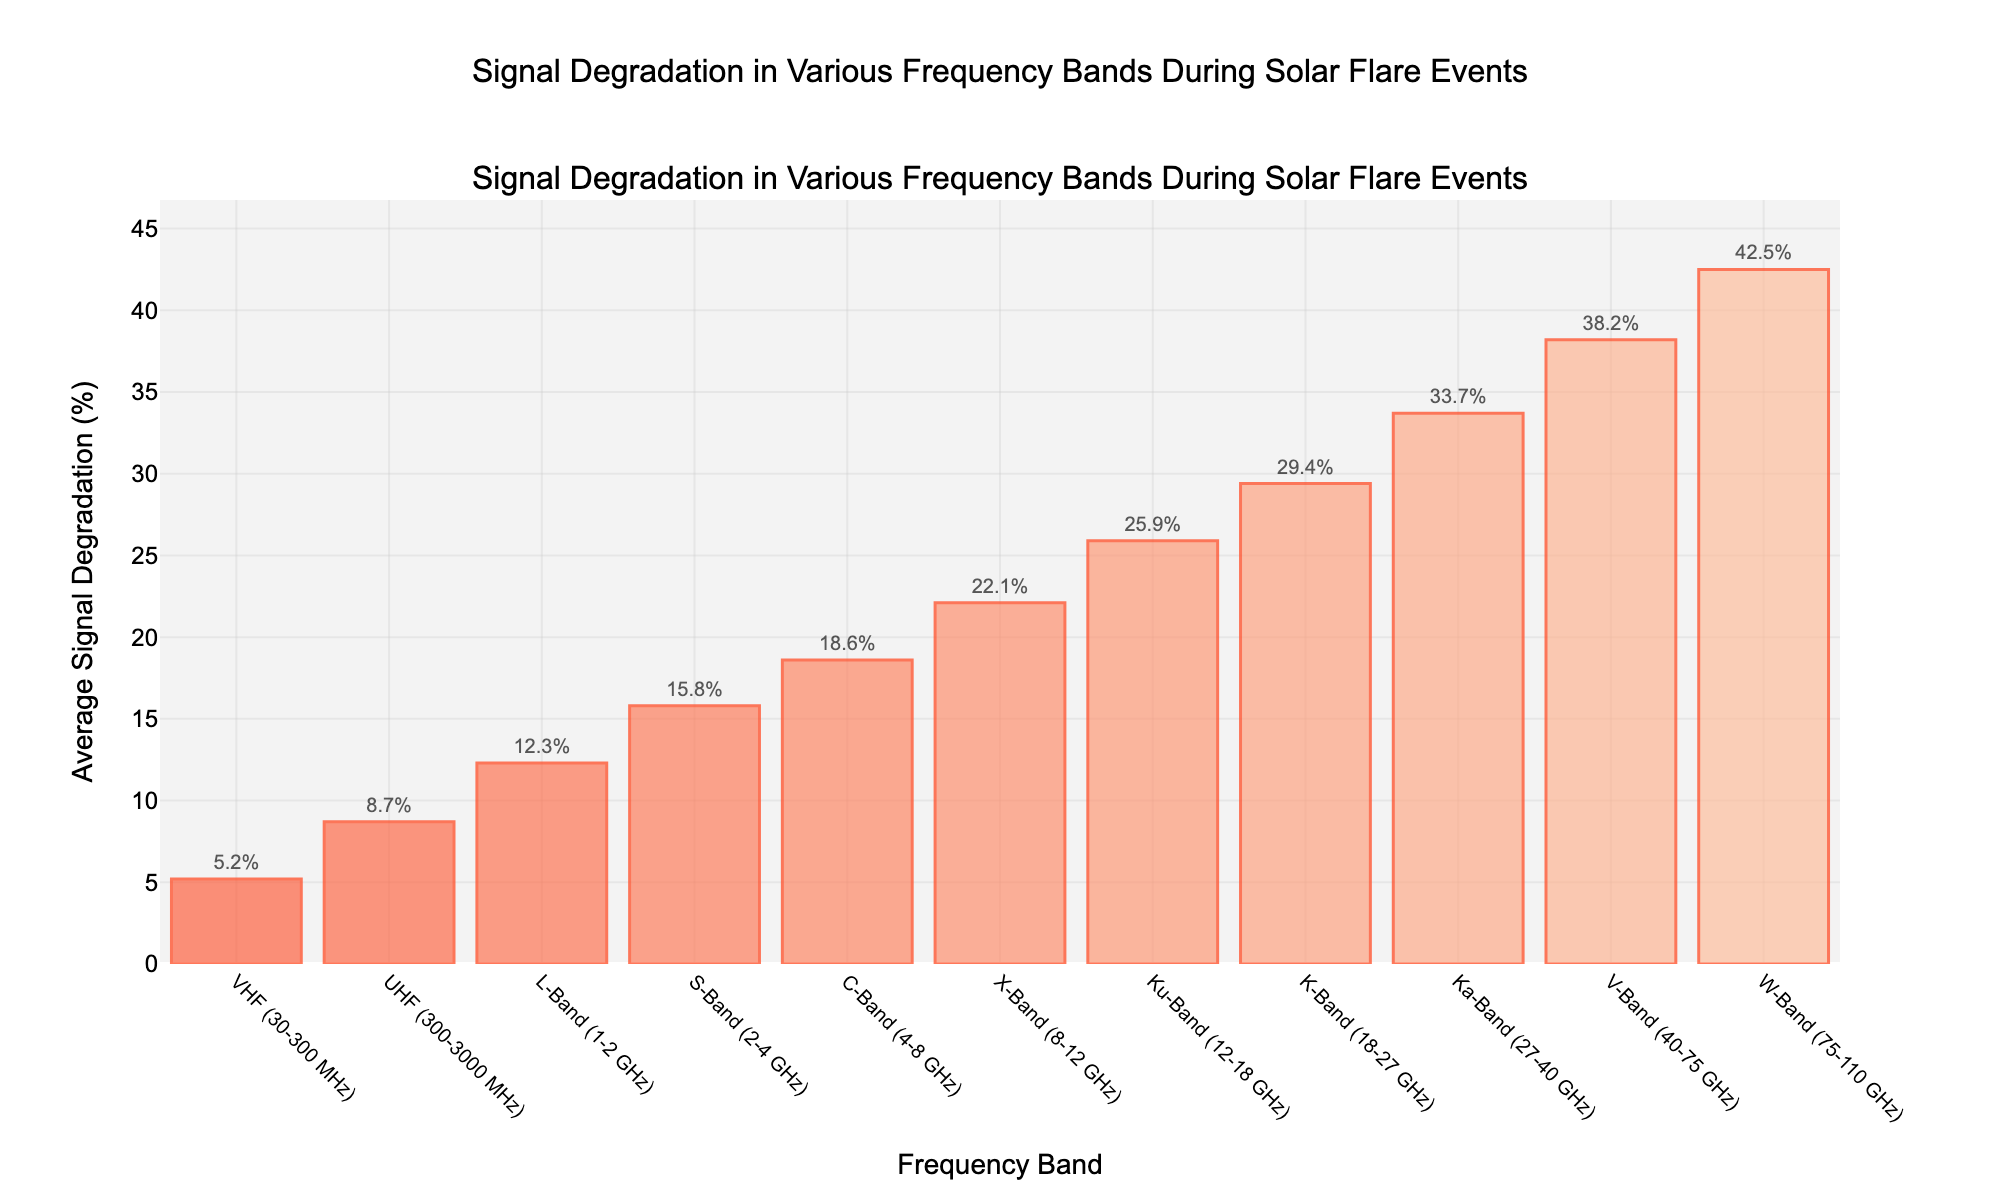What is the highest average signal degradation percentage, and in which frequency band does it occur? To find the highest average signal degradation percentage, we look for the tallest bar in the chart. The tallest bar represents the "W-Band (75-110 GHz)" with a value of 42.5%.
Answer: 42.5%, W-Band Which frequency band has a higher average signal degradation: S-Band or Ku-Band? First, locate the bars for the S-Band and the Ku-Band. The S-Band has an average signal degradation of 15.8%, and the Ku-Band has 25.9%. Comparing these values, the Ku-Band has a higher degradation.
Answer: Ku-Band What is the average signal degradation for the frequency bands above 10 GHz? Frequency bands above 10 GHz are X-Band, Ku-Band, K-Band, Ka-Band, V-Band, and W-Band. Their values are 22.1%, 25.9%, 29.4%, 33.7%, 38.2%, and 42.5% respectively. The average is calculated as (22.1 + 25.9 + 29.4 + 33.7 + 38.2 + 42.5) / 6 ≈ 32.0%.
Answer: 32.0% What are the colors used to represent the bars? The bars are represented in shades of red, starting from lighter shades for lower frequency bands and becoming progressively darker for higher frequency bands.
Answer: Shades of red Is the average signal degradation of the C-Band greater than the VHF Band? If so, by how much? The C-Band degradation is 18.6%, and the VHF Band is 5.2%. Subtracting these values, 18.6% - 5.2% = 13.4%. Thus, C-Band is greater by 13.4%.
Answer: Yes, 13.4% Which frequency band has the second-highest average signal degradation? The second-highest bar in the chart corresponds to the "V-Band (40-75 GHz)" with a value of 38.2%. The highest is W-Band, followed by V-Band.
Answer: V-Band What is the total signal degradation percentage for the frequency bands from 1-10 GHz? The frequency bands from 1-10 GHz are L-Band (12.3%), S-Band (15.8%), and C-Band (18.6%). Adding these values: 12.3 + 15.8 + 18.6 = 46.7%.
Answer: 46.7% How much more average signal degradation does the Ka-Band experience than the L-Band? The Ka-Band has 33.7%, and the L-Band has 12.3%. The difference is 33.7% - 12.3% = 21.4%.
Answer: 21.4% 